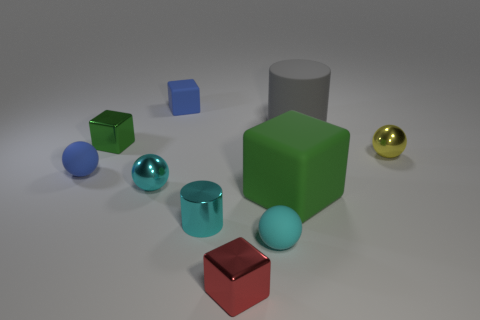Subtract all tiny cubes. How many cubes are left? 1 Subtract all cylinders. How many objects are left? 8 Subtract all gray cylinders. How many cyan spheres are left? 2 Subtract all gray cylinders. How many cylinders are left? 1 Subtract all purple cylinders. Subtract all brown spheres. How many cylinders are left? 2 Subtract all small yellow metallic things. Subtract all tiny cyan objects. How many objects are left? 6 Add 2 small blue cubes. How many small blue cubes are left? 3 Add 5 big gray cylinders. How many big gray cylinders exist? 6 Subtract 0 purple spheres. How many objects are left? 10 Subtract 4 blocks. How many blocks are left? 0 